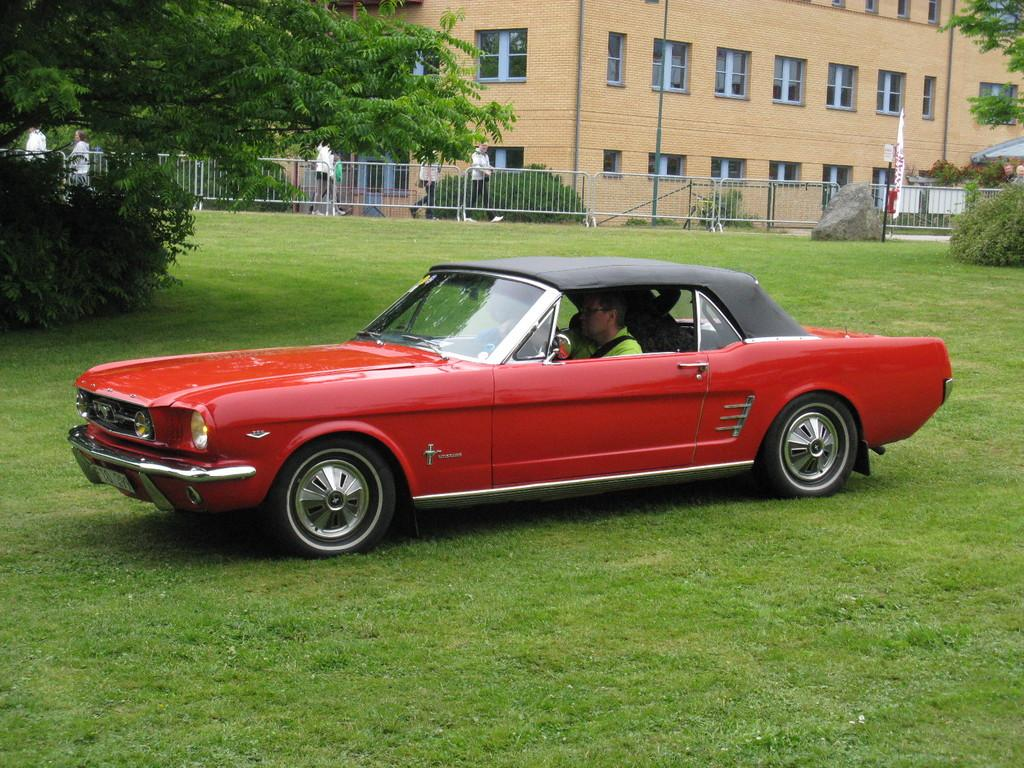What type of vegetation can be seen in the image? There is grass and plants visible in the image. What color is the car in the image? The car in the image is red. What type of structure is present in the image? There is a building in the image. What is used to separate areas in the image? There is a fence in the image. What can be seen through the windows in the image? The windows in the image provide a view of the surrounding environment. What type of flag is being waved by the loaf of bread in the image? There is no flag or loaf of bread present in the image. What type of industry is depicted in the image? The image does not depict any specific industry; it features a red car, grass, plants, a fence, a building, windows, and people. 